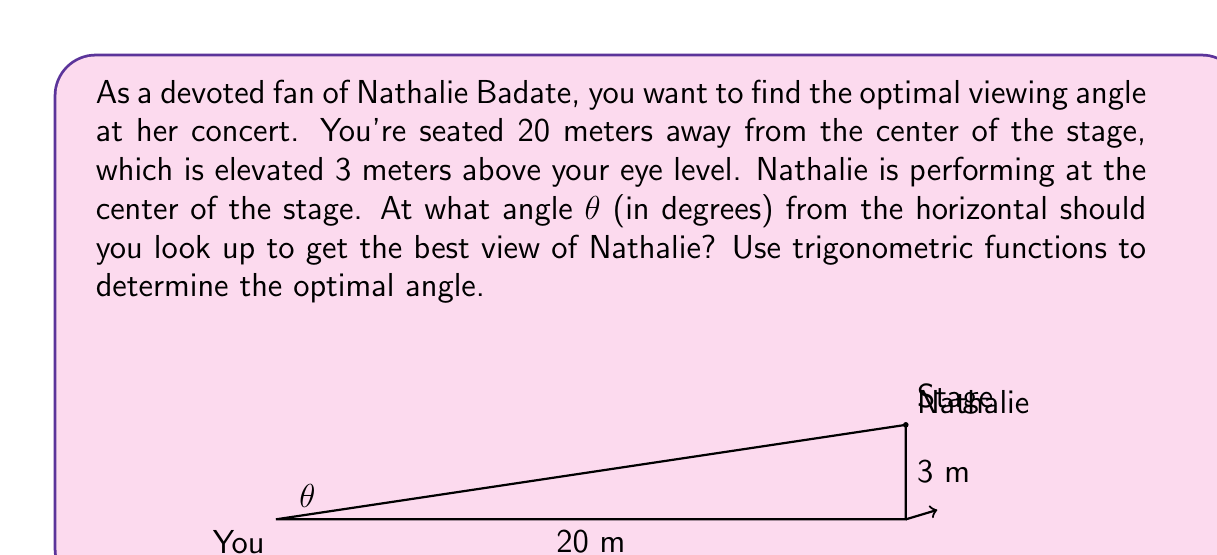Teach me how to tackle this problem. Let's approach this step-by-step:

1) We can visualize this scenario as a right-angled triangle, where:
   - The horizontal distance to the stage is the adjacent side (20 m)
   - The height of the stage is the opposite side (3 m)
   - The line of sight from you to Nathalie is the hypotenuse

2) To find the angle θ, we can use the arctangent function, as tangent is the ratio of opposite to adjacent in a right triangle.

3) The tangent of the angle θ is:

   $$\tan(\theta) = \frac{\text{opposite}}{\text{adjacent}} = \frac{3}{20} = 0.15$$

4) To find θ, we need to take the inverse tangent (arctangent) of this ratio:

   $$\theta = \arctan(0.15)$$

5) Using a calculator or computer, we can evaluate this:

   $$\theta \approx 8.53^\circ$$

6) This angle is in radians. To convert to degrees, we multiply by $\frac{180}{\pi}$:

   $$\theta \approx 8.53^\circ \cdot \frac{180}{\pi} \approx 8.53^\circ$$

Therefore, the optimal angle to view Nathalie Badate on stage is approximately 8.53 degrees above the horizontal.
Answer: The optimal viewing angle is approximately $8.53^\circ$ above the horizontal. 